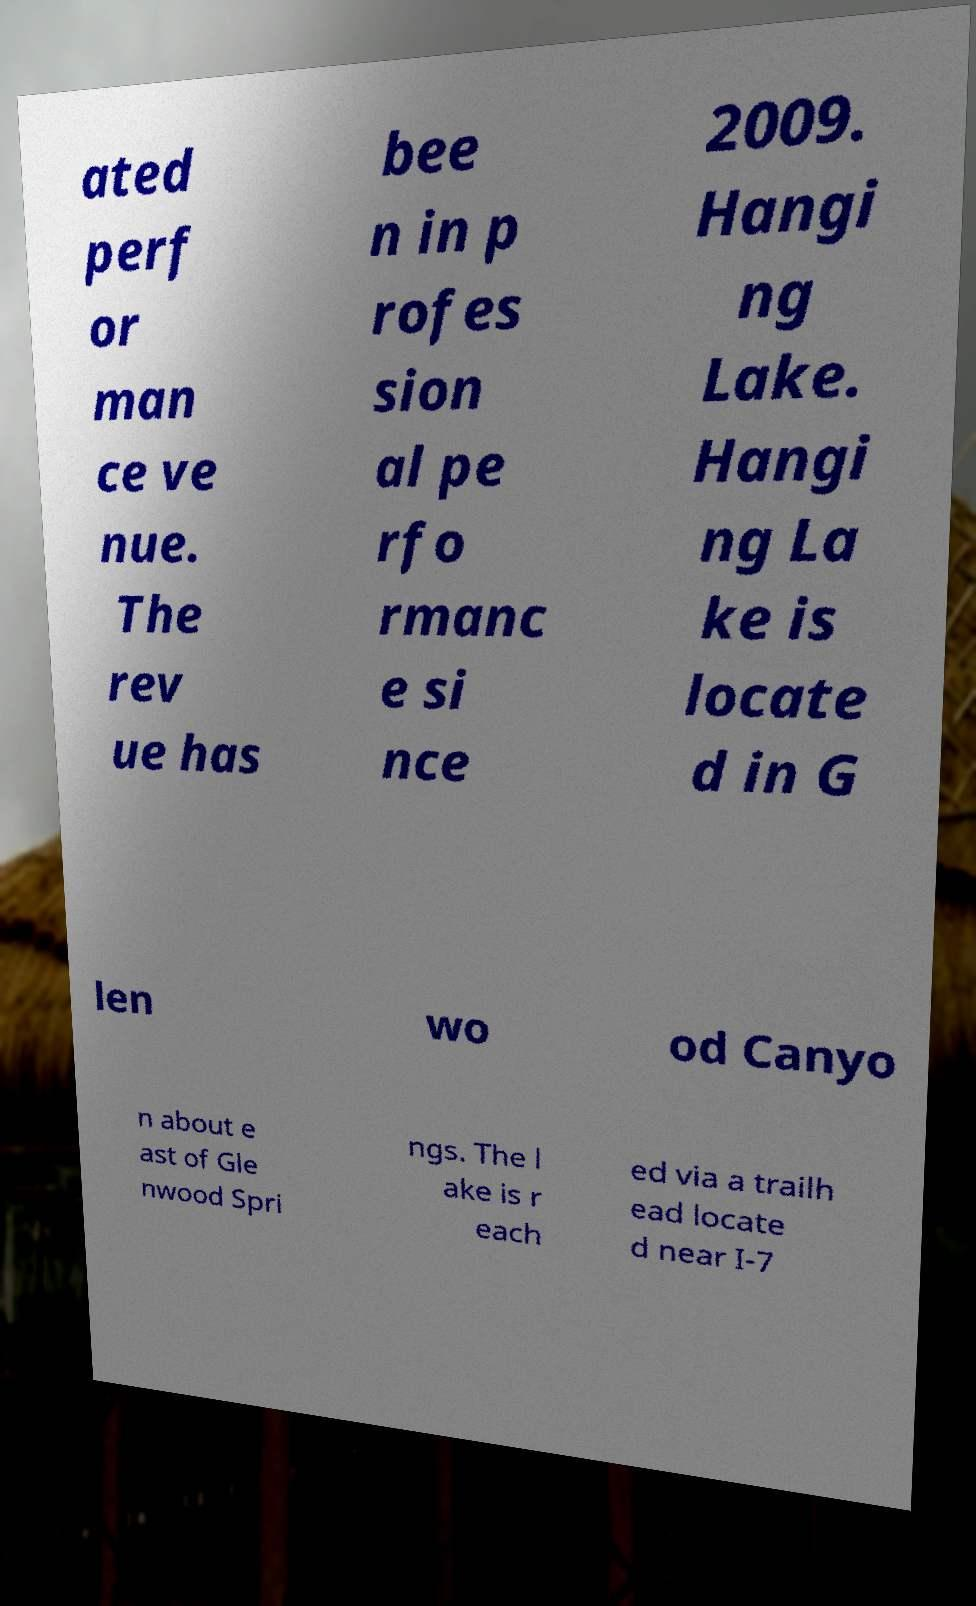Please read and relay the text visible in this image. What does it say? ated perf or man ce ve nue. The rev ue has bee n in p rofes sion al pe rfo rmanc e si nce 2009. Hangi ng Lake. Hangi ng La ke is locate d in G len wo od Canyo n about e ast of Gle nwood Spri ngs. The l ake is r each ed via a trailh ead locate d near I-7 